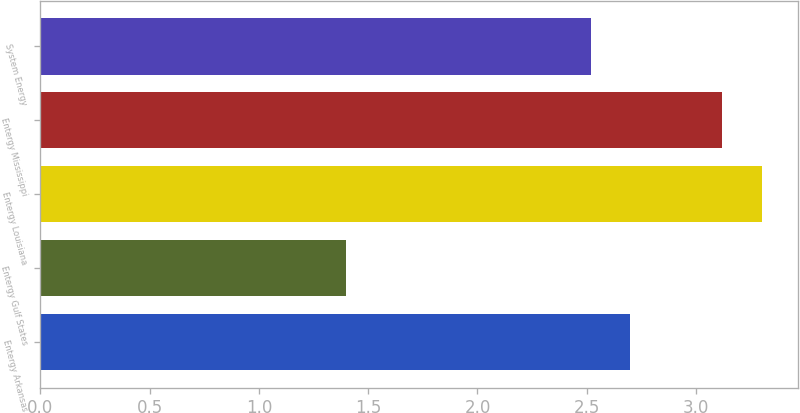Convert chart to OTSL. <chart><loc_0><loc_0><loc_500><loc_500><bar_chart><fcel>Entergy Arkansas<fcel>Entergy Gulf States<fcel>Entergy Louisiana<fcel>Entergy Mississippi<fcel>System Energy<nl><fcel>2.7<fcel>1.4<fcel>3.3<fcel>3.12<fcel>2.52<nl></chart> 